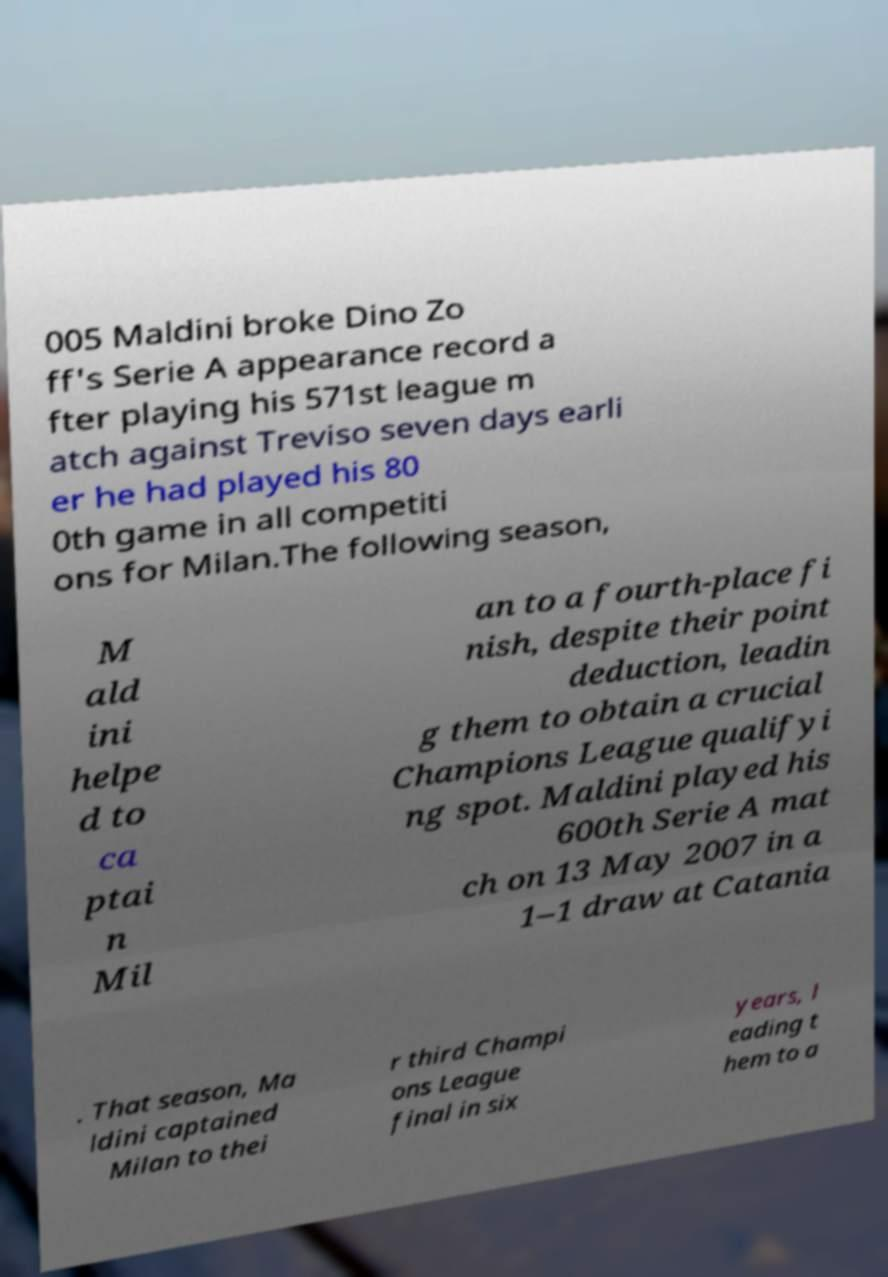Can you read and provide the text displayed in the image?This photo seems to have some interesting text. Can you extract and type it out for me? 005 Maldini broke Dino Zo ff's Serie A appearance record a fter playing his 571st league m atch against Treviso seven days earli er he had played his 80 0th game in all competiti ons for Milan.The following season, M ald ini helpe d to ca ptai n Mil an to a fourth-place fi nish, despite their point deduction, leadin g them to obtain a crucial Champions League qualifyi ng spot. Maldini played his 600th Serie A mat ch on 13 May 2007 in a 1–1 draw at Catania . That season, Ma ldini captained Milan to thei r third Champi ons League final in six years, l eading t hem to a 